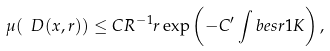Convert formula to latex. <formula><loc_0><loc_0><loc_500><loc_500>\mu ( \ D ( x , r ) ) \leq C R ^ { - 1 } r \exp \left ( - C ^ { \prime } \int b e s r 1 K \right ) ,</formula> 